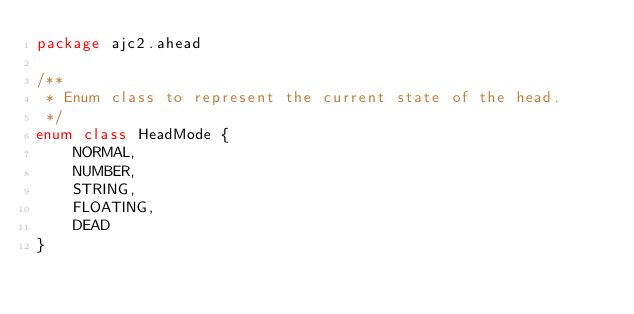Convert code to text. <code><loc_0><loc_0><loc_500><loc_500><_Kotlin_>package ajc2.ahead

/**
 * Enum class to represent the current state of the head.
 */
enum class HeadMode {
    NORMAL,
    NUMBER,
    STRING,
    FLOATING,
    DEAD
}
</code> 